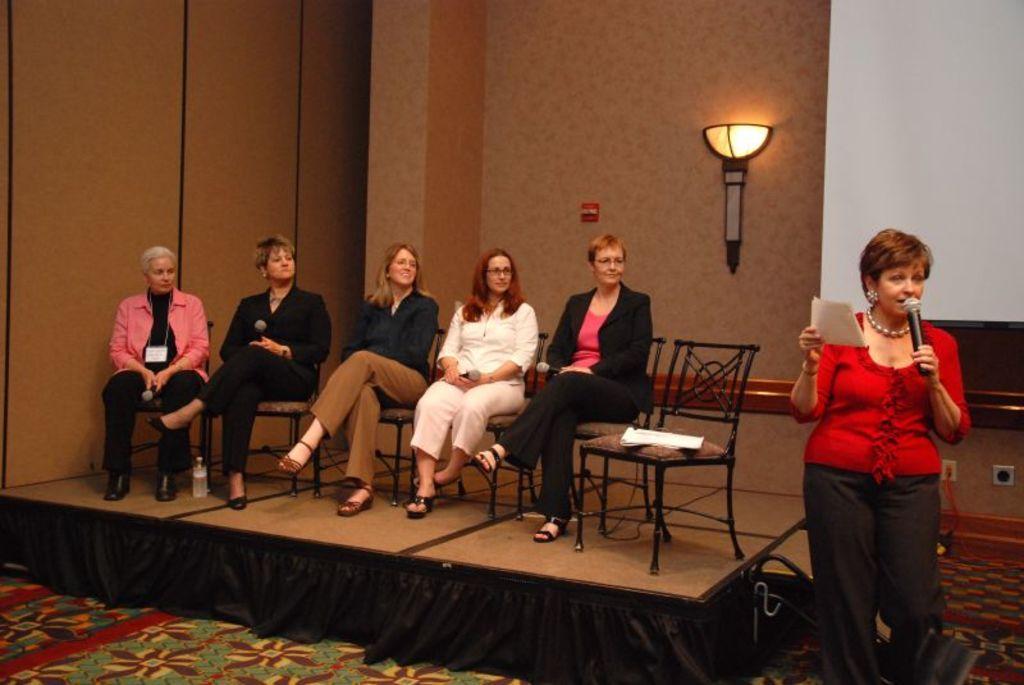In one or two sentences, can you explain what this image depicts? At the right side of the image there is a lady with red top and holding the mic in her hand and she is standing. And in the middle of the image there is a stage with few ladies are sitting on the chairs. Behind them there is a brown wall with a lamp on it. At the right top corner of the image there is a white screen. 